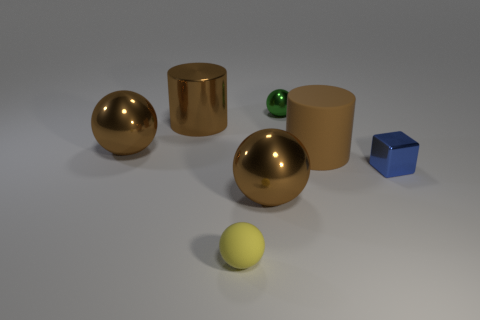Subtract all green balls. How many balls are left? 3 Subtract all small green metal spheres. How many spheres are left? 3 Add 1 small blue shiny cubes. How many objects exist? 8 Subtract 0 yellow blocks. How many objects are left? 7 Subtract all cubes. How many objects are left? 6 Subtract 3 balls. How many balls are left? 1 Subtract all brown cubes. Subtract all cyan spheres. How many cubes are left? 1 Subtract all green cylinders. How many yellow balls are left? 1 Subtract all tiny green shiny objects. Subtract all yellow objects. How many objects are left? 5 Add 3 spheres. How many spheres are left? 7 